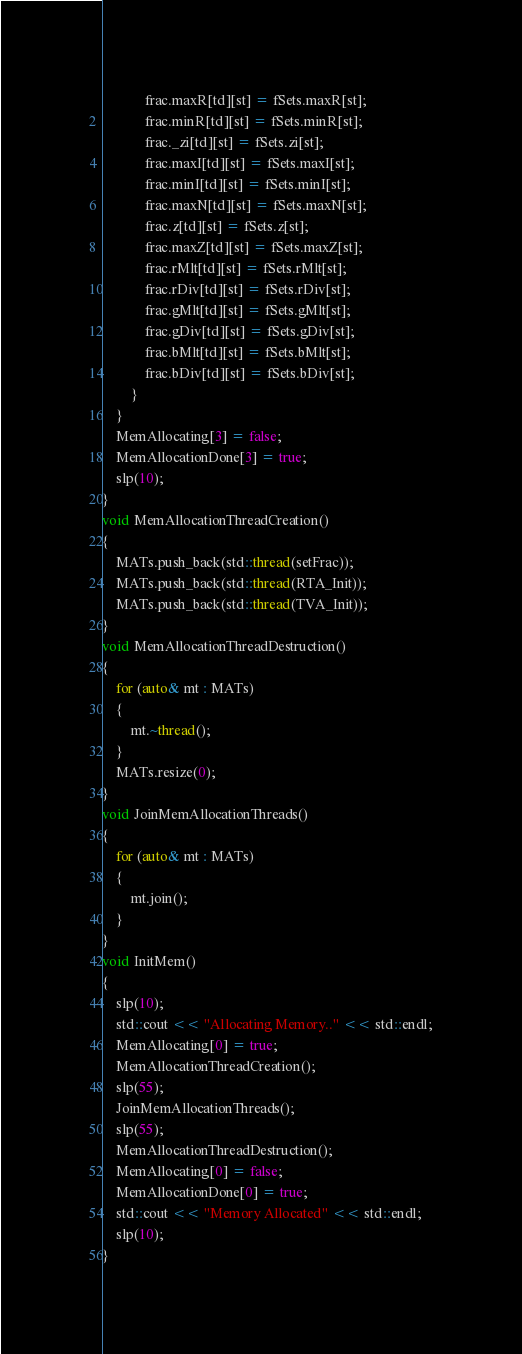<code> <loc_0><loc_0><loc_500><loc_500><_C++_>			frac.maxR[td][st] = fSets.maxR[st];
			frac.minR[td][st] = fSets.minR[st];
			frac._zi[td][st] = fSets.zi[st];
			frac.maxI[td][st] = fSets.maxI[st];
			frac.minI[td][st] = fSets.minI[st];
			frac.maxN[td][st] = fSets.maxN[st];
			frac.z[td][st] = fSets.z[st];
			frac.maxZ[td][st] = fSets.maxZ[st];
			frac.rMlt[td][st] = fSets.rMlt[st];
			frac.rDiv[td][st] = fSets.rDiv[st];
			frac.gMlt[td][st] = fSets.gMlt[st];
			frac.gDiv[td][st] = fSets.gDiv[st];
			frac.bMlt[td][st] = fSets.bMlt[st];
			frac.bDiv[td][st] = fSets.bDiv[st];
		}
	}
	MemAllocating[3] = false;
	MemAllocationDone[3] = true;
	slp(10);
}
void MemAllocationThreadCreation() 
{
	MATs.push_back(std::thread(setFrac));
	MATs.push_back(std::thread(RTA_Init));
	MATs.push_back(std::thread(TVA_Init));
}
void MemAllocationThreadDestruction() 
{
	for (auto& mt : MATs)
	{
		mt.~thread();
	}
	MATs.resize(0);
}
void JoinMemAllocationThreads() 
{
	for (auto& mt : MATs)
	{
		mt.join();
	}
}
void InitMem() 
{
	slp(10);
	std::cout << "Allocating Memory.." << std::endl;
	MemAllocating[0] = true;
	MemAllocationThreadCreation();
	slp(55);
	JoinMemAllocationThreads();
	slp(55);
	MemAllocationThreadDestruction();
	MemAllocating[0] = false;
	MemAllocationDone[0] = true;
	std::cout << "Memory Allocated" << std::endl;
	slp(10);
}</code> 